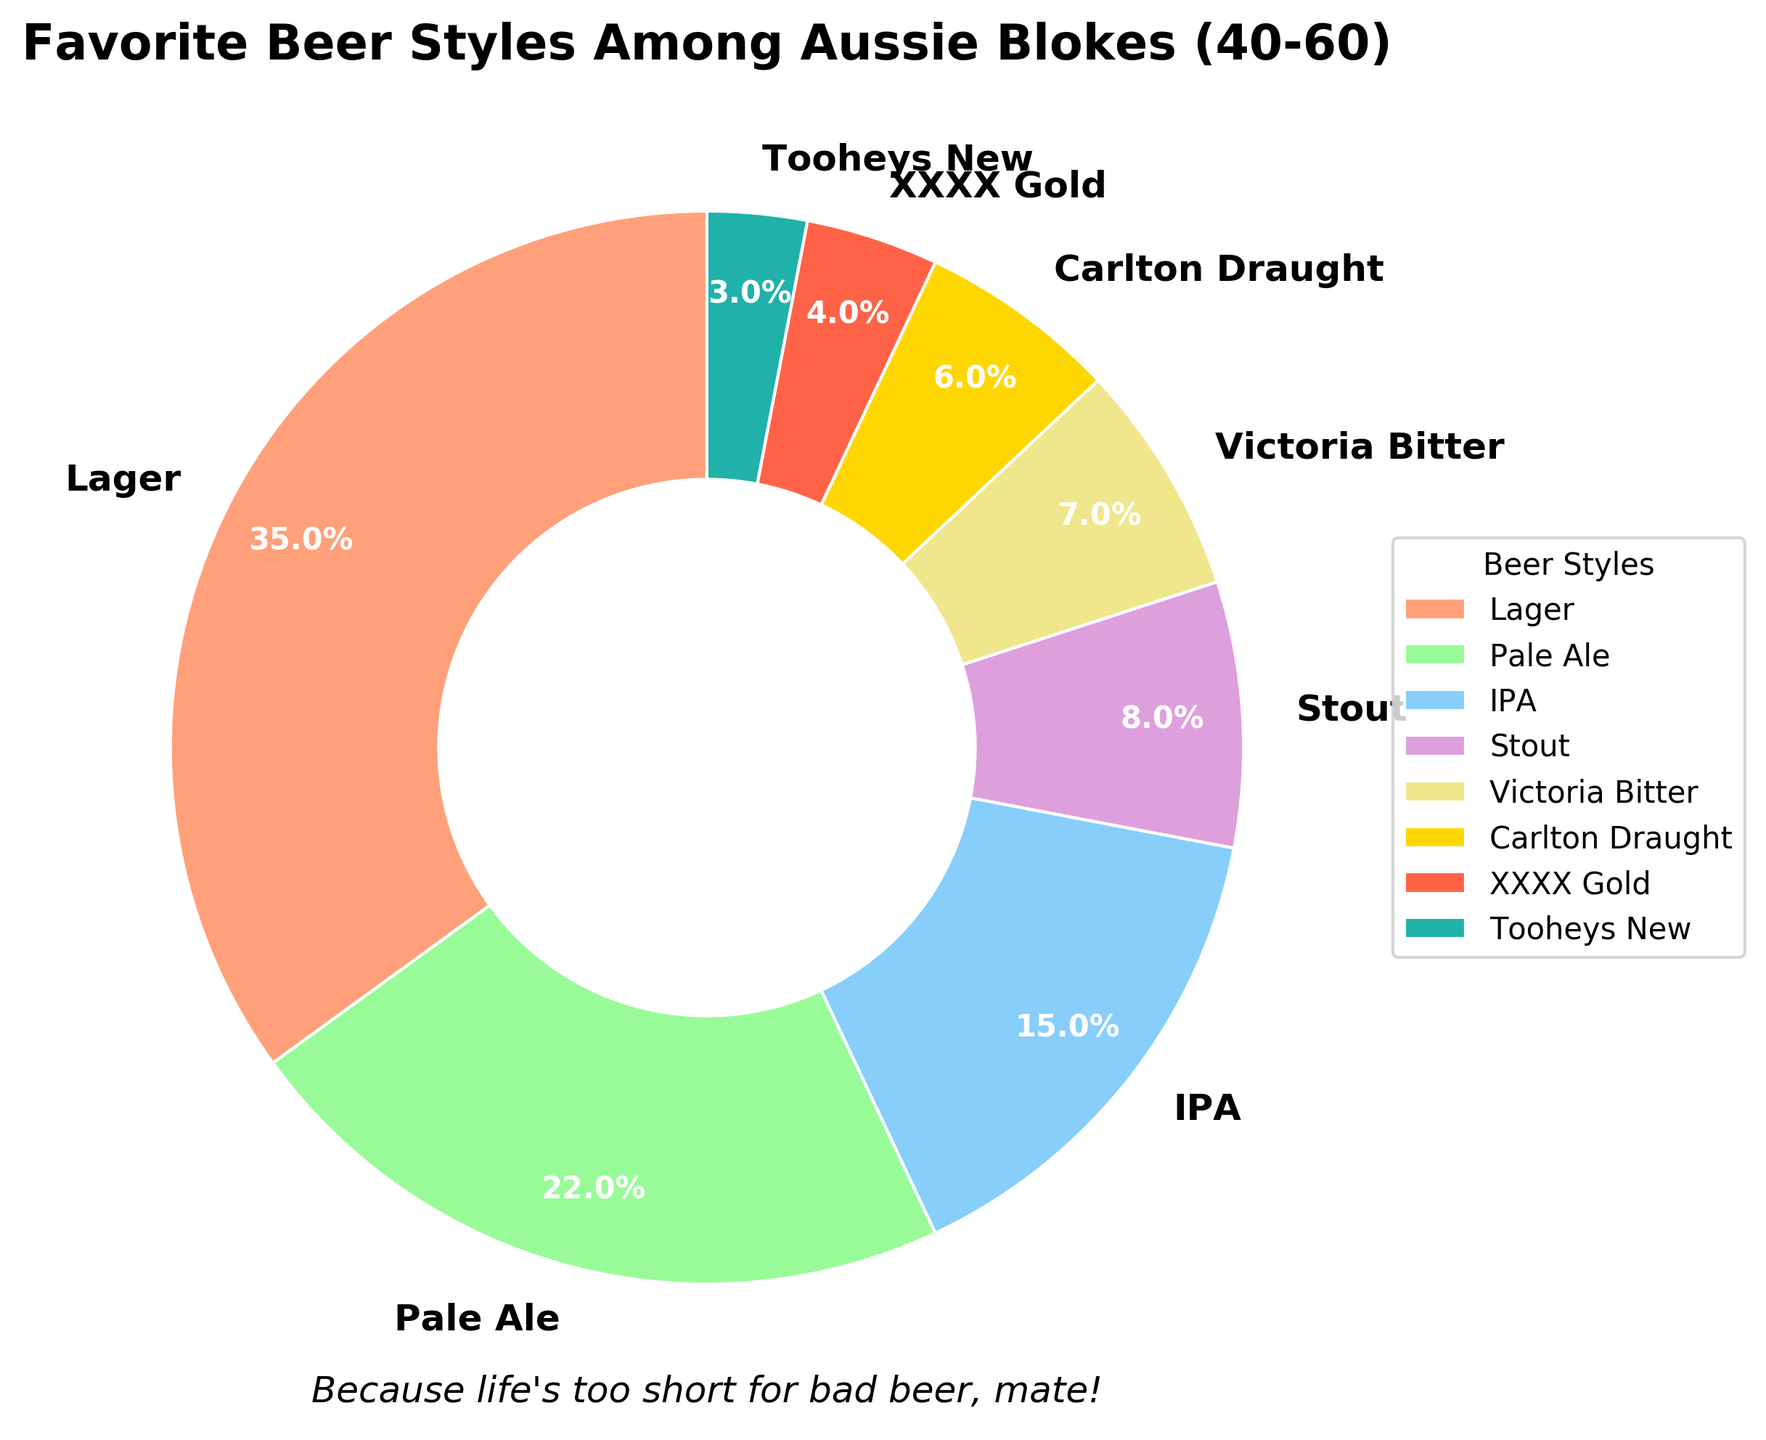What percentage of Aussie blokes aged 40-60 prefer Lager? The slice representing Lager shows 35%.
Answer: 35% Which beer styles have a lower preference than IPA? By comparing the size of the slices, IPA is preferred more than Stout, Victoria Bitter, Carlton Draught, XXXX Gold, and Tooheys New.
Answer: Stout, Victoria Bitter, Carlton Draught, XXXX Gold, Tooheys New Which beer style has the smallest percentage, and what is it? The smallest slice on the pie chart corresponds to Tooheys New.
Answer: Tooheys New, 3% What is the combined percentage of Lager and Pale Ale? Add the percentages of Lager (35%) and Pale Ale (22%): 35 + 22 = 57
Answer: 57% Is the percentage of Carlton Draught greater than that of Victoria Bitter? Carlton Draught's slice shows 6%, while Victoria Bitter's shows 7%. Therefore, Victoria Bitter has a greater percentage.
Answer: No What is the total percentage of all beer styles other than Lager and Pale Ale? Subtract the combined percentage of Lager and Pale Ale from 100%. Lager and Pale Ale together are 35% + 22% = 57%. So, 100% - 57% = 43%.
Answer: 43% Which beer style has a green slice, and what percentage does it represent? The green slice represents Pale Ale, which is 22%.
Answer: Pale Ale, 22% Are Stout and Victoria Bitter evenly preferred? Compare their slices visually. Stout is 8%, while Victoria Bitter is 7%. Therefore, they are not evenly preferred.
Answer: No What's the difference in preference between Pale Ale and XXXX Gold? Subtract the percentage of XXXX Gold from that of Pale Ale: 22% - 4% = 18%.
Answer: 18% Of the remaining beer styles, which one has the highest preference after Lager and Pale Ale? After Lager and Pale Ale, the remaining styles are IPA, Stout, Victoria Bitter, Carlton Draught, XXXX Gold, and Tooheys New. The largest slice among these is IPA, which is 15%.
Answer: IPA 